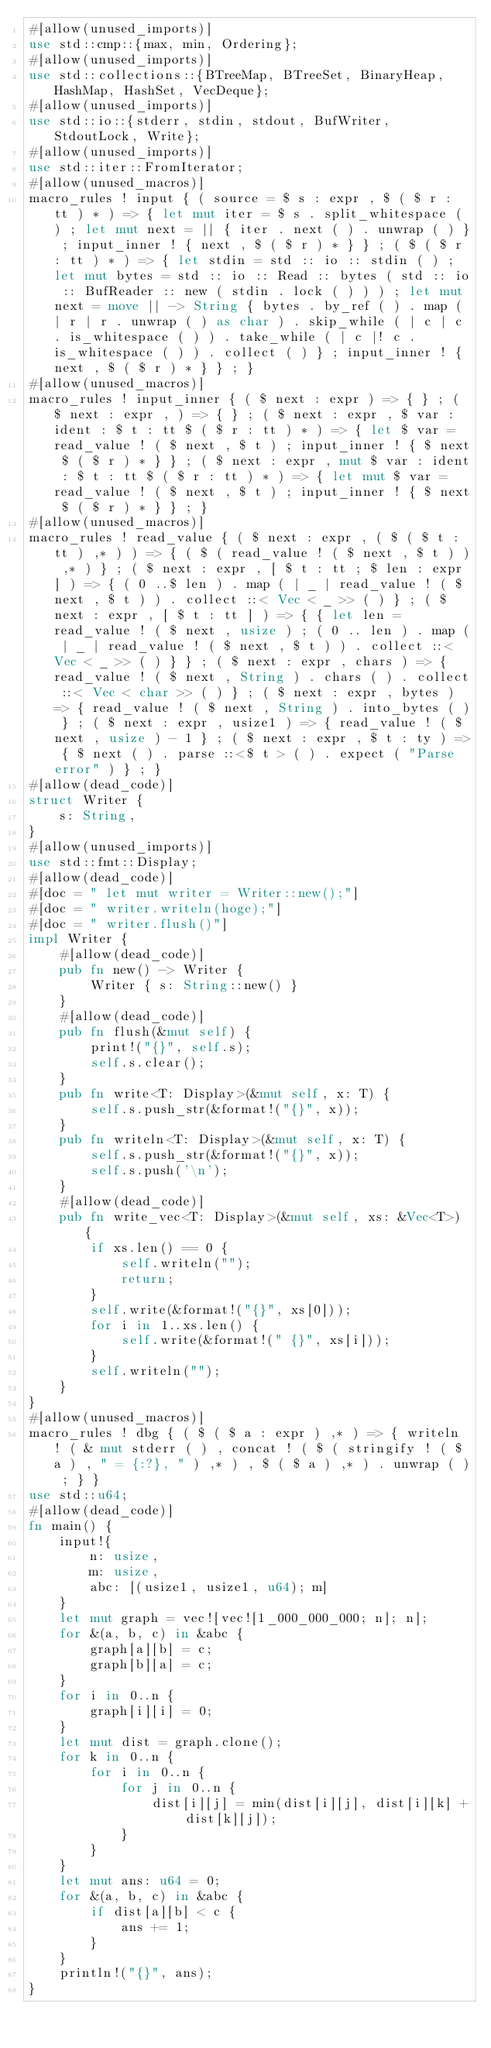<code> <loc_0><loc_0><loc_500><loc_500><_Rust_>#[allow(unused_imports)]
use std::cmp::{max, min, Ordering};
#[allow(unused_imports)]
use std::collections::{BTreeMap, BTreeSet, BinaryHeap, HashMap, HashSet, VecDeque};
#[allow(unused_imports)]
use std::io::{stderr, stdin, stdout, BufWriter, StdoutLock, Write};
#[allow(unused_imports)]
use std::iter::FromIterator;
#[allow(unused_macros)]
macro_rules ! input { ( source = $ s : expr , $ ( $ r : tt ) * ) => { let mut iter = $ s . split_whitespace ( ) ; let mut next = || { iter . next ( ) . unwrap ( ) } ; input_inner ! { next , $ ( $ r ) * } } ; ( $ ( $ r : tt ) * ) => { let stdin = std :: io :: stdin ( ) ; let mut bytes = std :: io :: Read :: bytes ( std :: io :: BufReader :: new ( stdin . lock ( ) ) ) ; let mut next = move || -> String { bytes . by_ref ( ) . map ( | r | r . unwrap ( ) as char ) . skip_while ( | c | c . is_whitespace ( ) ) . take_while ( | c |! c . is_whitespace ( ) ) . collect ( ) } ; input_inner ! { next , $ ( $ r ) * } } ; }
#[allow(unused_macros)]
macro_rules ! input_inner { ( $ next : expr ) => { } ; ( $ next : expr , ) => { } ; ( $ next : expr , $ var : ident : $ t : tt $ ( $ r : tt ) * ) => { let $ var = read_value ! ( $ next , $ t ) ; input_inner ! { $ next $ ( $ r ) * } } ; ( $ next : expr , mut $ var : ident : $ t : tt $ ( $ r : tt ) * ) => { let mut $ var = read_value ! ( $ next , $ t ) ; input_inner ! { $ next $ ( $ r ) * } } ; }
#[allow(unused_macros)]
macro_rules ! read_value { ( $ next : expr , ( $ ( $ t : tt ) ,* ) ) => { ( $ ( read_value ! ( $ next , $ t ) ) ,* ) } ; ( $ next : expr , [ $ t : tt ; $ len : expr ] ) => { ( 0 ..$ len ) . map ( | _ | read_value ! ( $ next , $ t ) ) . collect ::< Vec < _ >> ( ) } ; ( $ next : expr , [ $ t : tt ] ) => { { let len = read_value ! ( $ next , usize ) ; ( 0 .. len ) . map ( | _ | read_value ! ( $ next , $ t ) ) . collect ::< Vec < _ >> ( ) } } ; ( $ next : expr , chars ) => { read_value ! ( $ next , String ) . chars ( ) . collect ::< Vec < char >> ( ) } ; ( $ next : expr , bytes ) => { read_value ! ( $ next , String ) . into_bytes ( ) } ; ( $ next : expr , usize1 ) => { read_value ! ( $ next , usize ) - 1 } ; ( $ next : expr , $ t : ty ) => { $ next ( ) . parse ::<$ t > ( ) . expect ( "Parse error" ) } ; }
#[allow(dead_code)]
struct Writer {
    s: String,
}
#[allow(unused_imports)]
use std::fmt::Display;
#[allow(dead_code)]
#[doc = " let mut writer = Writer::new();"]
#[doc = " writer.writeln(hoge);"]
#[doc = " writer.flush()"]
impl Writer {
    #[allow(dead_code)]
    pub fn new() -> Writer {
        Writer { s: String::new() }
    }
    #[allow(dead_code)]
    pub fn flush(&mut self) {
        print!("{}", self.s);
        self.s.clear();
    }
    pub fn write<T: Display>(&mut self, x: T) {
        self.s.push_str(&format!("{}", x));
    }
    pub fn writeln<T: Display>(&mut self, x: T) {
        self.s.push_str(&format!("{}", x));
        self.s.push('\n');
    }
    #[allow(dead_code)]
    pub fn write_vec<T: Display>(&mut self, xs: &Vec<T>) {
        if xs.len() == 0 {
            self.writeln("");
            return;
        }
        self.write(&format!("{}", xs[0]));
        for i in 1..xs.len() {
            self.write(&format!(" {}", xs[i]));
        }
        self.writeln("");
    }
}
#[allow(unused_macros)]
macro_rules ! dbg { ( $ ( $ a : expr ) ,* ) => { writeln ! ( & mut stderr ( ) , concat ! ( $ ( stringify ! ( $ a ) , " = {:?}, " ) ,* ) , $ ( $ a ) ,* ) . unwrap ( ) ; } }
use std::u64;
#[allow(dead_code)]
fn main() {
    input!{
        n: usize,
        m: usize,
        abc: [(usize1, usize1, u64); m]
    }
    let mut graph = vec![vec![1_000_000_000; n]; n];
    for &(a, b, c) in &abc {
        graph[a][b] = c;
        graph[b][a] = c;
    }
    for i in 0..n {
        graph[i][i] = 0;
    }
    let mut dist = graph.clone();
    for k in 0..n {
        for i in 0..n {
            for j in 0..n {
                dist[i][j] = min(dist[i][j], dist[i][k] + dist[k][j]);
            }
        }
    }
    let mut ans: u64 = 0;
    for &(a, b, c) in &abc {
        if dist[a][b] < c {
            ans += 1;
        }
    }
    println!("{}", ans);
}</code> 